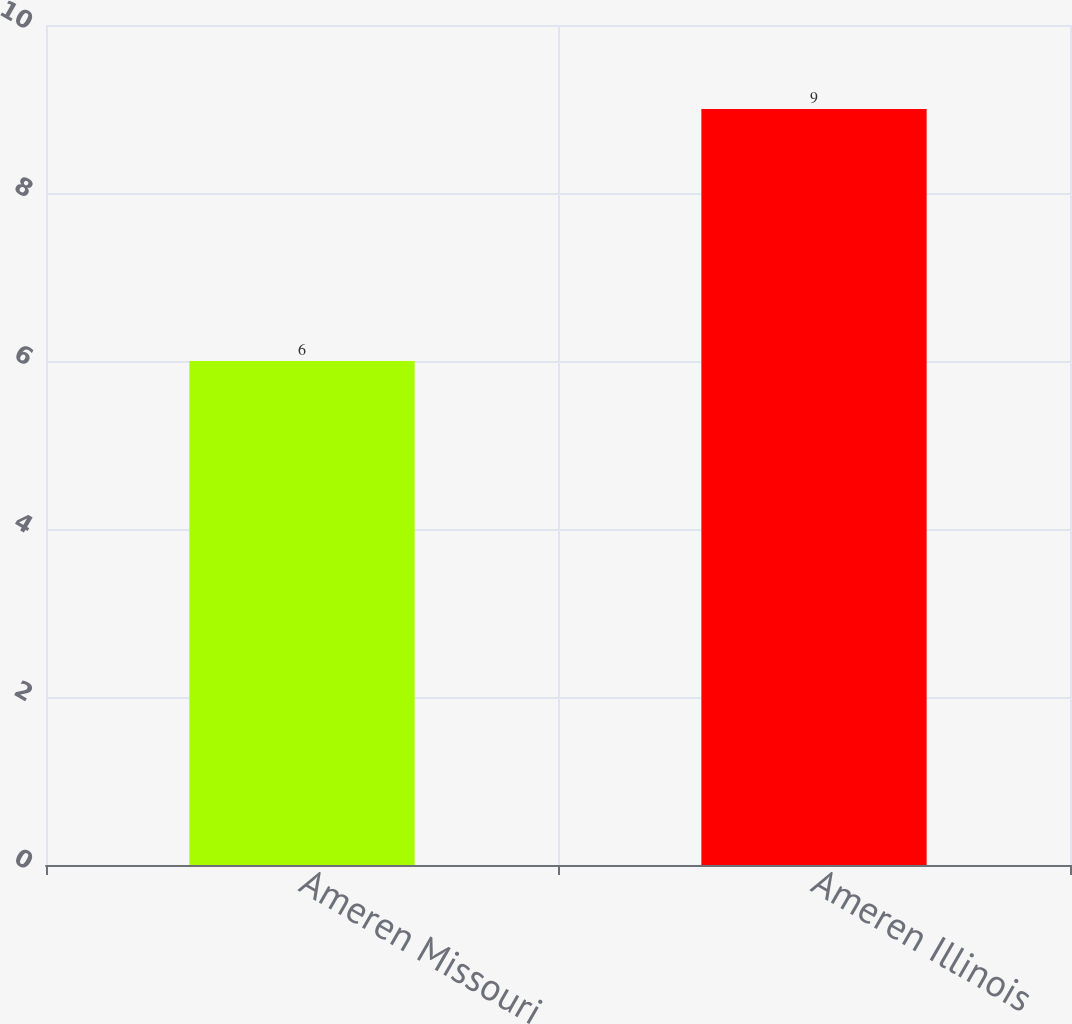Convert chart to OTSL. <chart><loc_0><loc_0><loc_500><loc_500><bar_chart><fcel>Ameren Missouri<fcel>Ameren Illinois<nl><fcel>6<fcel>9<nl></chart> 